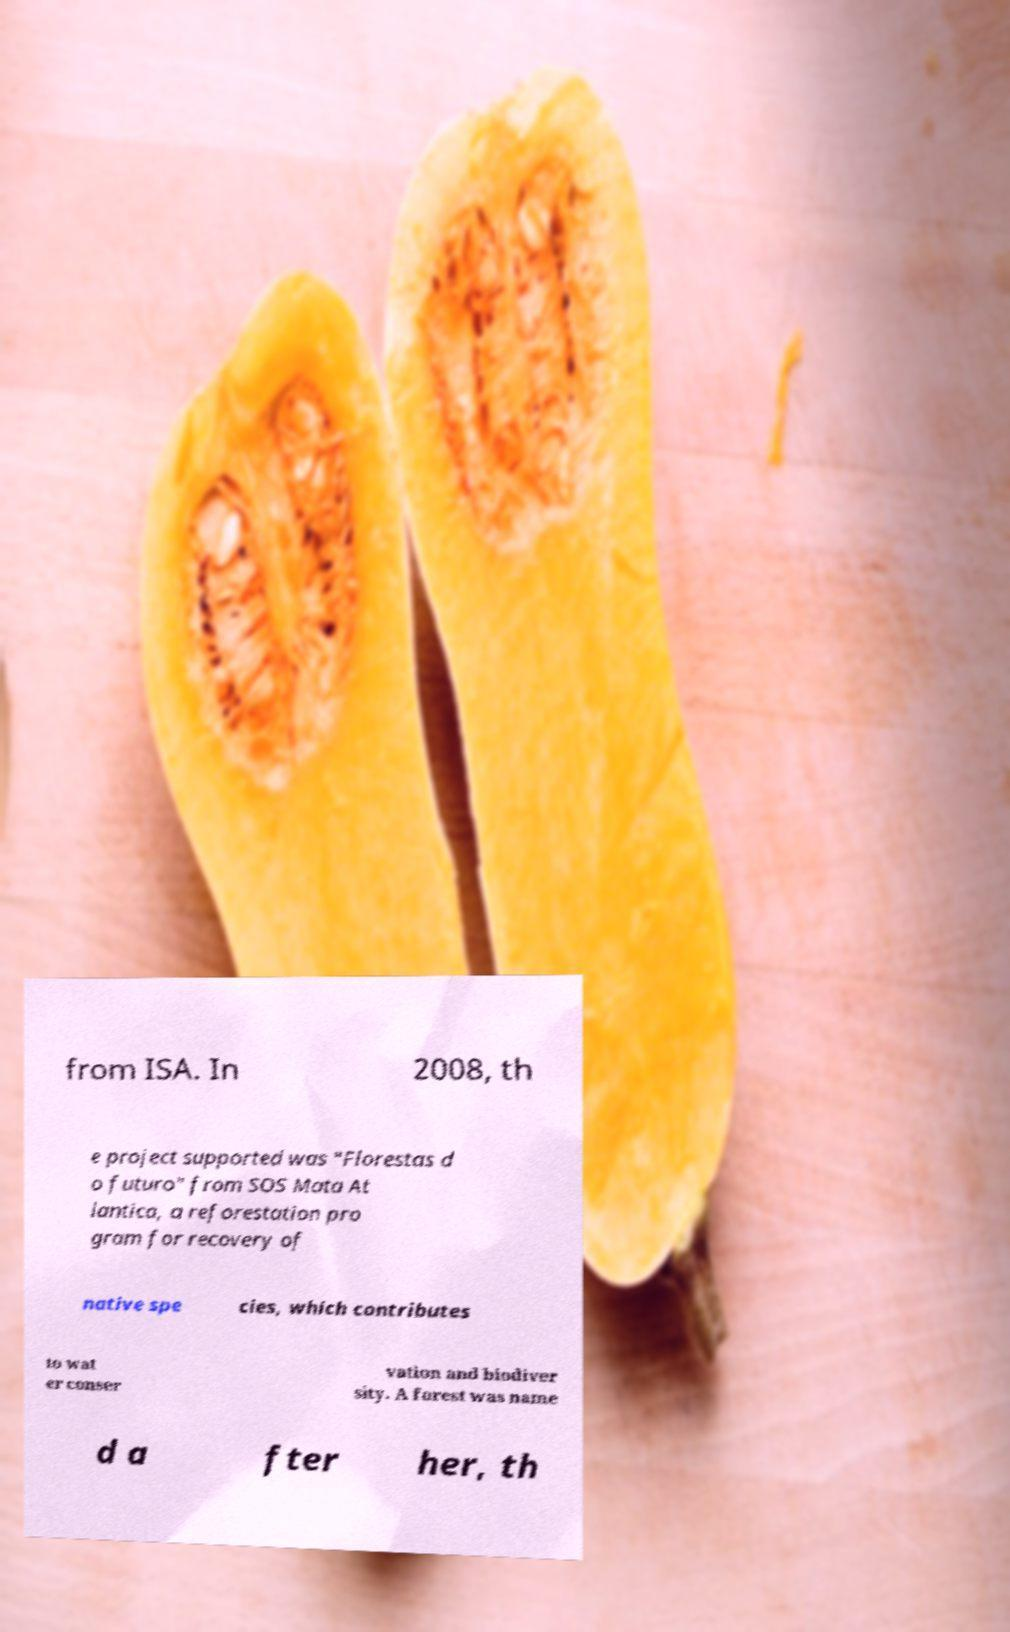Can you accurately transcribe the text from the provided image for me? from ISA. In 2008, th e project supported was "Florestas d o futuro" from SOS Mata At lantica, a reforestation pro gram for recovery of native spe cies, which contributes to wat er conser vation and biodiver sity. A forest was name d a fter her, th 